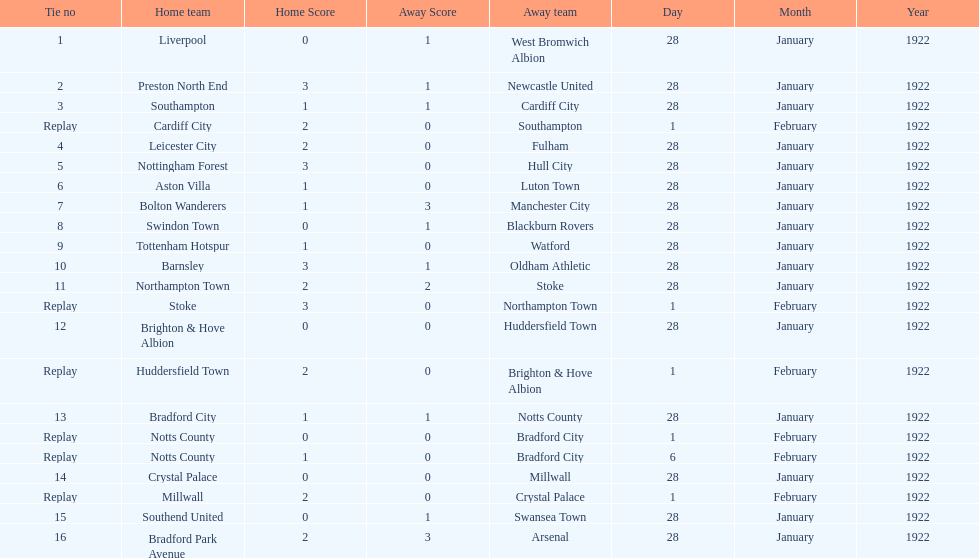How many games had four total points scored or more? 5. Give me the full table as a dictionary. {'header': ['Tie no', 'Home team', 'Home Score', 'Away Score', 'Away team', 'Day', 'Month', 'Year'], 'rows': [['1', 'Liverpool', '0', '1', 'West Bromwich Albion', '28', 'January', '1922'], ['2', 'Preston North End', '3', '1', 'Newcastle United', '28', 'January', '1922'], ['3', 'Southampton', '1', '1', 'Cardiff City', '28', 'January', '1922'], ['Replay', 'Cardiff City', '2', '0', 'Southampton', '1', 'February', '1922'], ['4', 'Leicester City', '2', '0', 'Fulham', '28', 'January', '1922'], ['5', 'Nottingham Forest', '3', '0', 'Hull City', '28', 'January', '1922'], ['6', 'Aston Villa', '1', '0', 'Luton Town', '28', 'January', '1922'], ['7', 'Bolton Wanderers', '1', '3', 'Manchester City', '28', 'January', '1922'], ['8', 'Swindon Town', '0', '1', 'Blackburn Rovers', '28', 'January', '1922'], ['9', 'Tottenham Hotspur', '1', '0', 'Watford', '28', 'January', '1922'], ['10', 'Barnsley', '3', '1', 'Oldham Athletic', '28', 'January', '1922'], ['11', 'Northampton Town', '2', '2', 'Stoke', '28', 'January', '1922'], ['Replay', 'Stoke', '3', '0', 'Northampton Town', '1', 'February', '1922'], ['12', 'Brighton & Hove Albion', '0', '0', 'Huddersfield Town', '28', 'January', '1922'], ['Replay', 'Huddersfield Town', '2', '0', 'Brighton & Hove Albion', '1', 'February', '1922'], ['13', 'Bradford City', '1', '1', 'Notts County', '28', 'January', '1922'], ['Replay', 'Notts County', '0', '0', 'Bradford City', '1', 'February', '1922'], ['Replay', 'Notts County', '1', '0', 'Bradford City', '6', 'February', '1922'], ['14', 'Crystal Palace', '0', '0', 'Millwall', '28', 'January', '1922'], ['Replay', 'Millwall', '2', '0', 'Crystal Palace', '1', 'February', '1922'], ['15', 'Southend United', '0', '1', 'Swansea Town', '28', 'January', '1922'], ['16', 'Bradford Park Avenue', '2', '3', 'Arsenal', '28', 'January', '1922']]} 